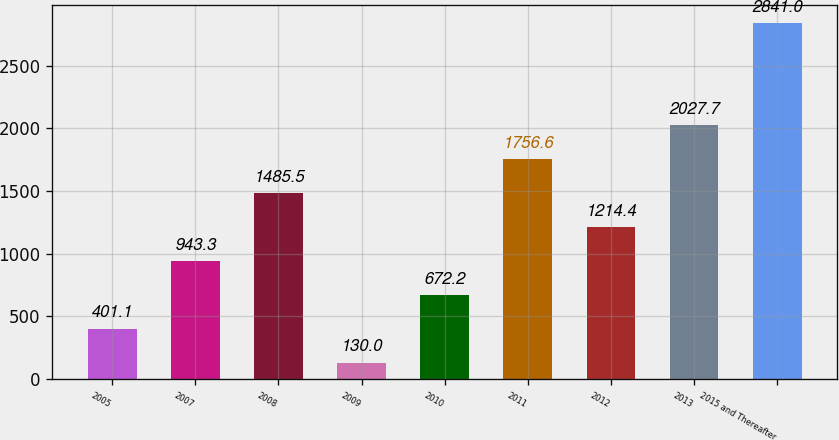Convert chart. <chart><loc_0><loc_0><loc_500><loc_500><bar_chart><fcel>2005<fcel>2007<fcel>2008<fcel>2009<fcel>2010<fcel>2011<fcel>2012<fcel>2013<fcel>2015 and Thereafter<nl><fcel>401.1<fcel>943.3<fcel>1485.5<fcel>130<fcel>672.2<fcel>1756.6<fcel>1214.4<fcel>2027.7<fcel>2841<nl></chart> 